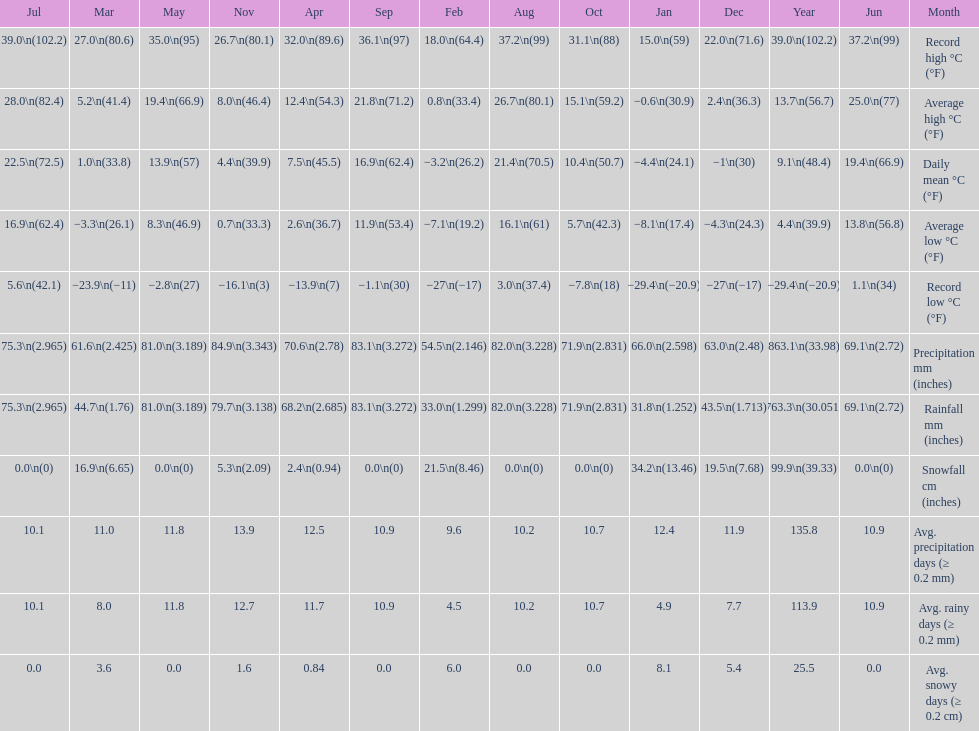Between january, october and december which month had the most rainfall? October. 